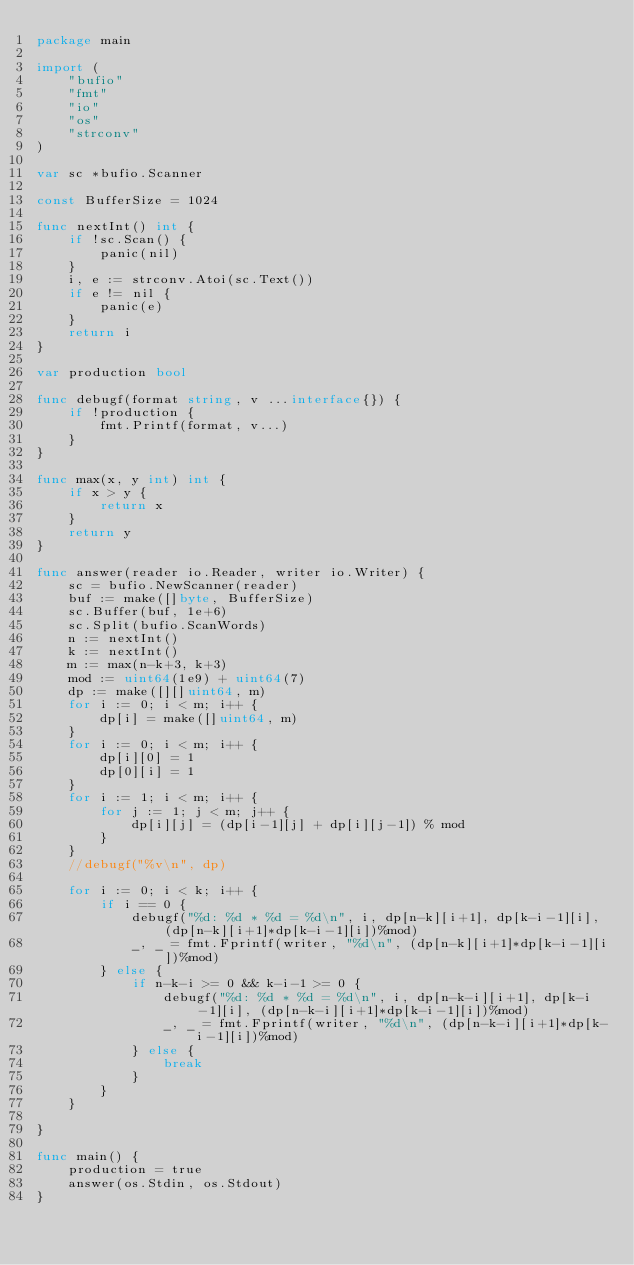<code> <loc_0><loc_0><loc_500><loc_500><_Go_>package main

import (
	"bufio"
	"fmt"
	"io"
	"os"
	"strconv"
)

var sc *bufio.Scanner

const BufferSize = 1024

func nextInt() int {
	if !sc.Scan() {
		panic(nil)
	}
	i, e := strconv.Atoi(sc.Text())
	if e != nil {
		panic(e)
	}
	return i
}

var production bool

func debugf(format string, v ...interface{}) {
	if !production {
		fmt.Printf(format, v...)
	}
}

func max(x, y int) int {
	if x > y {
		return x
	}
	return y
}

func answer(reader io.Reader, writer io.Writer) {
	sc = bufio.NewScanner(reader)
	buf := make([]byte, BufferSize)
	sc.Buffer(buf, 1e+6)
	sc.Split(bufio.ScanWords)
	n := nextInt()
	k := nextInt()
	m := max(n-k+3, k+3)
	mod := uint64(1e9) + uint64(7)
	dp := make([][]uint64, m)
	for i := 0; i < m; i++ {
		dp[i] = make([]uint64, m)
	}
	for i := 0; i < m; i++ {
		dp[i][0] = 1
		dp[0][i] = 1
	}
	for i := 1; i < m; i++ {
		for j := 1; j < m; j++ {
			dp[i][j] = (dp[i-1][j] + dp[i][j-1]) % mod
		}
	}
	//debugf("%v\n", dp)

	for i := 0; i < k; i++ {
		if i == 0 {
			debugf("%d: %d * %d = %d\n", i, dp[n-k][i+1], dp[k-i-1][i], (dp[n-k][i+1]*dp[k-i-1][i])%mod)
			_, _ = fmt.Fprintf(writer, "%d\n", (dp[n-k][i+1]*dp[k-i-1][i])%mod)
		} else {
			if n-k-i >= 0 && k-i-1 >= 0 {
				debugf("%d: %d * %d = %d\n", i, dp[n-k-i][i+1], dp[k-i-1][i], (dp[n-k-i][i+1]*dp[k-i-1][i])%mod)
				_, _ = fmt.Fprintf(writer, "%d\n", (dp[n-k-i][i+1]*dp[k-i-1][i])%mod)
			} else {
				break
			}
		}
	}

}

func main() {
	production = true
	answer(os.Stdin, os.Stdout)
}
</code> 